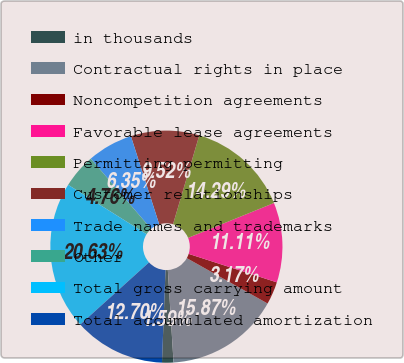Convert chart. <chart><loc_0><loc_0><loc_500><loc_500><pie_chart><fcel>in thousands<fcel>Contractual rights in place<fcel>Noncompetition agreements<fcel>Favorable lease agreements<fcel>Permitting permitting<fcel>Customer relationships<fcel>Trade names and trademarks<fcel>Other<fcel>Total gross carrying amount<fcel>Total accumulated amortization<nl><fcel>1.59%<fcel>15.87%<fcel>3.17%<fcel>11.11%<fcel>14.29%<fcel>9.52%<fcel>6.35%<fcel>4.76%<fcel>20.63%<fcel>12.7%<nl></chart> 